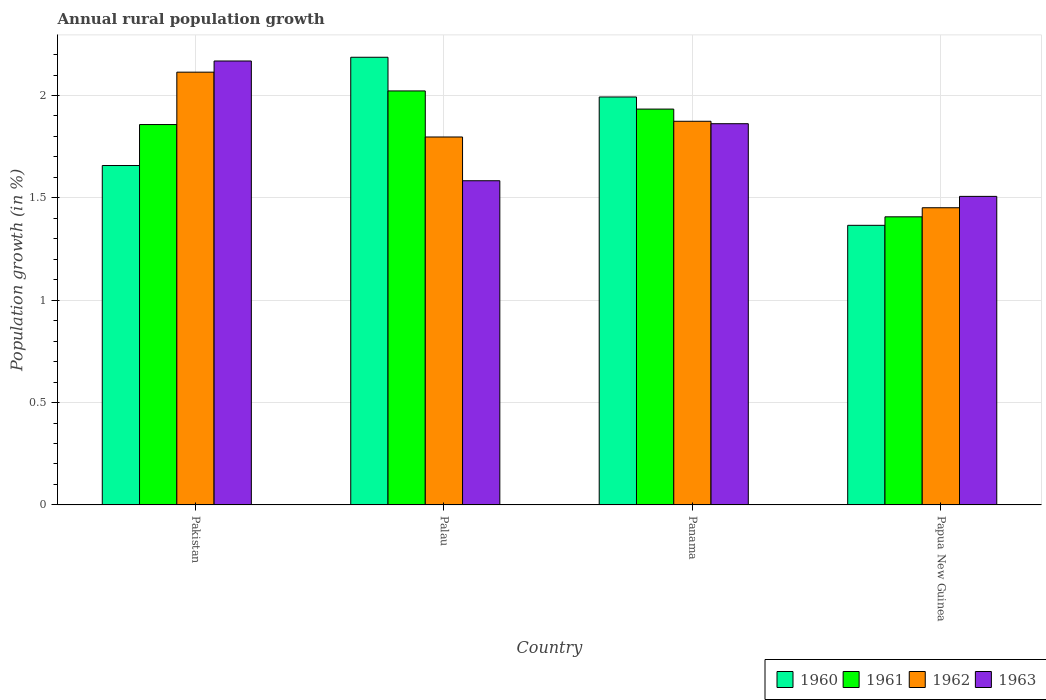Are the number of bars on each tick of the X-axis equal?
Provide a succinct answer. Yes. How many bars are there on the 3rd tick from the right?
Offer a very short reply. 4. What is the label of the 3rd group of bars from the left?
Offer a terse response. Panama. What is the percentage of rural population growth in 1960 in Papua New Guinea?
Your answer should be very brief. 1.37. Across all countries, what is the maximum percentage of rural population growth in 1962?
Provide a succinct answer. 2.11. Across all countries, what is the minimum percentage of rural population growth in 1961?
Make the answer very short. 1.41. In which country was the percentage of rural population growth in 1962 maximum?
Provide a short and direct response. Pakistan. In which country was the percentage of rural population growth in 1963 minimum?
Offer a terse response. Papua New Guinea. What is the total percentage of rural population growth in 1963 in the graph?
Provide a short and direct response. 7.12. What is the difference between the percentage of rural population growth in 1960 in Pakistan and that in Panama?
Your answer should be compact. -0.33. What is the difference between the percentage of rural population growth in 1963 in Pakistan and the percentage of rural population growth in 1961 in Palau?
Keep it short and to the point. 0.15. What is the average percentage of rural population growth in 1962 per country?
Ensure brevity in your answer.  1.81. What is the difference between the percentage of rural population growth of/in 1961 and percentage of rural population growth of/in 1963 in Palau?
Offer a terse response. 0.44. In how many countries, is the percentage of rural population growth in 1961 greater than 0.9 %?
Ensure brevity in your answer.  4. What is the ratio of the percentage of rural population growth in 1963 in Pakistan to that in Palau?
Provide a succinct answer. 1.37. Is the difference between the percentage of rural population growth in 1961 in Palau and Panama greater than the difference between the percentage of rural population growth in 1963 in Palau and Panama?
Provide a short and direct response. Yes. What is the difference between the highest and the second highest percentage of rural population growth in 1962?
Your answer should be compact. -0.24. What is the difference between the highest and the lowest percentage of rural population growth in 1963?
Ensure brevity in your answer.  0.66. In how many countries, is the percentage of rural population growth in 1961 greater than the average percentage of rural population growth in 1961 taken over all countries?
Provide a short and direct response. 3. What does the 4th bar from the left in Palau represents?
Give a very brief answer. 1963. How many countries are there in the graph?
Your response must be concise. 4. Are the values on the major ticks of Y-axis written in scientific E-notation?
Give a very brief answer. No. Does the graph contain grids?
Keep it short and to the point. Yes. What is the title of the graph?
Offer a terse response. Annual rural population growth. Does "1998" appear as one of the legend labels in the graph?
Give a very brief answer. No. What is the label or title of the Y-axis?
Ensure brevity in your answer.  Population growth (in %). What is the Population growth (in %) in 1960 in Pakistan?
Offer a very short reply. 1.66. What is the Population growth (in %) of 1961 in Pakistan?
Offer a very short reply. 1.86. What is the Population growth (in %) in 1962 in Pakistan?
Your response must be concise. 2.11. What is the Population growth (in %) in 1963 in Pakistan?
Provide a short and direct response. 2.17. What is the Population growth (in %) in 1960 in Palau?
Offer a very short reply. 2.19. What is the Population growth (in %) of 1961 in Palau?
Offer a very short reply. 2.02. What is the Population growth (in %) of 1962 in Palau?
Provide a short and direct response. 1.8. What is the Population growth (in %) of 1963 in Palau?
Offer a terse response. 1.58. What is the Population growth (in %) of 1960 in Panama?
Offer a very short reply. 1.99. What is the Population growth (in %) of 1961 in Panama?
Your answer should be compact. 1.93. What is the Population growth (in %) in 1962 in Panama?
Provide a short and direct response. 1.87. What is the Population growth (in %) in 1963 in Panama?
Your answer should be very brief. 1.86. What is the Population growth (in %) in 1960 in Papua New Guinea?
Offer a very short reply. 1.37. What is the Population growth (in %) of 1961 in Papua New Guinea?
Provide a short and direct response. 1.41. What is the Population growth (in %) of 1962 in Papua New Guinea?
Provide a succinct answer. 1.45. What is the Population growth (in %) in 1963 in Papua New Guinea?
Make the answer very short. 1.51. Across all countries, what is the maximum Population growth (in %) in 1960?
Your answer should be very brief. 2.19. Across all countries, what is the maximum Population growth (in %) of 1961?
Keep it short and to the point. 2.02. Across all countries, what is the maximum Population growth (in %) in 1962?
Keep it short and to the point. 2.11. Across all countries, what is the maximum Population growth (in %) of 1963?
Offer a terse response. 2.17. Across all countries, what is the minimum Population growth (in %) in 1960?
Provide a succinct answer. 1.37. Across all countries, what is the minimum Population growth (in %) in 1961?
Ensure brevity in your answer.  1.41. Across all countries, what is the minimum Population growth (in %) in 1962?
Give a very brief answer. 1.45. Across all countries, what is the minimum Population growth (in %) of 1963?
Your answer should be compact. 1.51. What is the total Population growth (in %) of 1960 in the graph?
Give a very brief answer. 7.2. What is the total Population growth (in %) of 1961 in the graph?
Offer a very short reply. 7.22. What is the total Population growth (in %) of 1962 in the graph?
Provide a succinct answer. 7.24. What is the total Population growth (in %) in 1963 in the graph?
Give a very brief answer. 7.12. What is the difference between the Population growth (in %) of 1960 in Pakistan and that in Palau?
Your response must be concise. -0.53. What is the difference between the Population growth (in %) in 1961 in Pakistan and that in Palau?
Make the answer very short. -0.16. What is the difference between the Population growth (in %) of 1962 in Pakistan and that in Palau?
Give a very brief answer. 0.32. What is the difference between the Population growth (in %) in 1963 in Pakistan and that in Palau?
Offer a very short reply. 0.58. What is the difference between the Population growth (in %) of 1960 in Pakistan and that in Panama?
Offer a terse response. -0.33. What is the difference between the Population growth (in %) of 1961 in Pakistan and that in Panama?
Your answer should be compact. -0.08. What is the difference between the Population growth (in %) in 1962 in Pakistan and that in Panama?
Keep it short and to the point. 0.24. What is the difference between the Population growth (in %) of 1963 in Pakistan and that in Panama?
Provide a succinct answer. 0.31. What is the difference between the Population growth (in %) in 1960 in Pakistan and that in Papua New Guinea?
Ensure brevity in your answer.  0.29. What is the difference between the Population growth (in %) of 1961 in Pakistan and that in Papua New Guinea?
Your response must be concise. 0.45. What is the difference between the Population growth (in %) in 1962 in Pakistan and that in Papua New Guinea?
Give a very brief answer. 0.66. What is the difference between the Population growth (in %) of 1963 in Pakistan and that in Papua New Guinea?
Make the answer very short. 0.66. What is the difference between the Population growth (in %) in 1960 in Palau and that in Panama?
Offer a very short reply. 0.19. What is the difference between the Population growth (in %) of 1961 in Palau and that in Panama?
Provide a succinct answer. 0.09. What is the difference between the Population growth (in %) in 1962 in Palau and that in Panama?
Ensure brevity in your answer.  -0.08. What is the difference between the Population growth (in %) of 1963 in Palau and that in Panama?
Keep it short and to the point. -0.28. What is the difference between the Population growth (in %) in 1960 in Palau and that in Papua New Guinea?
Provide a succinct answer. 0.82. What is the difference between the Population growth (in %) of 1961 in Palau and that in Papua New Guinea?
Your response must be concise. 0.61. What is the difference between the Population growth (in %) of 1962 in Palau and that in Papua New Guinea?
Keep it short and to the point. 0.35. What is the difference between the Population growth (in %) of 1963 in Palau and that in Papua New Guinea?
Keep it short and to the point. 0.08. What is the difference between the Population growth (in %) of 1960 in Panama and that in Papua New Guinea?
Make the answer very short. 0.63. What is the difference between the Population growth (in %) in 1961 in Panama and that in Papua New Guinea?
Make the answer very short. 0.53. What is the difference between the Population growth (in %) of 1962 in Panama and that in Papua New Guinea?
Make the answer very short. 0.42. What is the difference between the Population growth (in %) of 1963 in Panama and that in Papua New Guinea?
Give a very brief answer. 0.35. What is the difference between the Population growth (in %) of 1960 in Pakistan and the Population growth (in %) of 1961 in Palau?
Provide a short and direct response. -0.36. What is the difference between the Population growth (in %) in 1960 in Pakistan and the Population growth (in %) in 1962 in Palau?
Make the answer very short. -0.14. What is the difference between the Population growth (in %) in 1960 in Pakistan and the Population growth (in %) in 1963 in Palau?
Your answer should be very brief. 0.07. What is the difference between the Population growth (in %) of 1961 in Pakistan and the Population growth (in %) of 1962 in Palau?
Offer a terse response. 0.06. What is the difference between the Population growth (in %) of 1961 in Pakistan and the Population growth (in %) of 1963 in Palau?
Provide a short and direct response. 0.27. What is the difference between the Population growth (in %) of 1962 in Pakistan and the Population growth (in %) of 1963 in Palau?
Provide a succinct answer. 0.53. What is the difference between the Population growth (in %) of 1960 in Pakistan and the Population growth (in %) of 1961 in Panama?
Offer a very short reply. -0.28. What is the difference between the Population growth (in %) of 1960 in Pakistan and the Population growth (in %) of 1962 in Panama?
Make the answer very short. -0.22. What is the difference between the Population growth (in %) in 1960 in Pakistan and the Population growth (in %) in 1963 in Panama?
Ensure brevity in your answer.  -0.2. What is the difference between the Population growth (in %) of 1961 in Pakistan and the Population growth (in %) of 1962 in Panama?
Your answer should be very brief. -0.02. What is the difference between the Population growth (in %) of 1961 in Pakistan and the Population growth (in %) of 1963 in Panama?
Your response must be concise. -0. What is the difference between the Population growth (in %) of 1962 in Pakistan and the Population growth (in %) of 1963 in Panama?
Provide a short and direct response. 0.25. What is the difference between the Population growth (in %) in 1960 in Pakistan and the Population growth (in %) in 1961 in Papua New Guinea?
Provide a short and direct response. 0.25. What is the difference between the Population growth (in %) in 1960 in Pakistan and the Population growth (in %) in 1962 in Papua New Guinea?
Provide a short and direct response. 0.21. What is the difference between the Population growth (in %) in 1960 in Pakistan and the Population growth (in %) in 1963 in Papua New Guinea?
Provide a short and direct response. 0.15. What is the difference between the Population growth (in %) in 1961 in Pakistan and the Population growth (in %) in 1962 in Papua New Guinea?
Make the answer very short. 0.41. What is the difference between the Population growth (in %) of 1961 in Pakistan and the Population growth (in %) of 1963 in Papua New Guinea?
Offer a terse response. 0.35. What is the difference between the Population growth (in %) in 1962 in Pakistan and the Population growth (in %) in 1963 in Papua New Guinea?
Keep it short and to the point. 0.61. What is the difference between the Population growth (in %) in 1960 in Palau and the Population growth (in %) in 1961 in Panama?
Your answer should be compact. 0.25. What is the difference between the Population growth (in %) of 1960 in Palau and the Population growth (in %) of 1962 in Panama?
Give a very brief answer. 0.31. What is the difference between the Population growth (in %) in 1960 in Palau and the Population growth (in %) in 1963 in Panama?
Your answer should be compact. 0.32. What is the difference between the Population growth (in %) in 1961 in Palau and the Population growth (in %) in 1962 in Panama?
Provide a succinct answer. 0.15. What is the difference between the Population growth (in %) of 1961 in Palau and the Population growth (in %) of 1963 in Panama?
Provide a succinct answer. 0.16. What is the difference between the Population growth (in %) of 1962 in Palau and the Population growth (in %) of 1963 in Panama?
Your answer should be very brief. -0.06. What is the difference between the Population growth (in %) of 1960 in Palau and the Population growth (in %) of 1961 in Papua New Guinea?
Provide a succinct answer. 0.78. What is the difference between the Population growth (in %) of 1960 in Palau and the Population growth (in %) of 1962 in Papua New Guinea?
Keep it short and to the point. 0.73. What is the difference between the Population growth (in %) of 1960 in Palau and the Population growth (in %) of 1963 in Papua New Guinea?
Your answer should be very brief. 0.68. What is the difference between the Population growth (in %) in 1961 in Palau and the Population growth (in %) in 1962 in Papua New Guinea?
Your answer should be very brief. 0.57. What is the difference between the Population growth (in %) of 1961 in Palau and the Population growth (in %) of 1963 in Papua New Guinea?
Provide a short and direct response. 0.52. What is the difference between the Population growth (in %) of 1962 in Palau and the Population growth (in %) of 1963 in Papua New Guinea?
Offer a terse response. 0.29. What is the difference between the Population growth (in %) in 1960 in Panama and the Population growth (in %) in 1961 in Papua New Guinea?
Ensure brevity in your answer.  0.59. What is the difference between the Population growth (in %) in 1960 in Panama and the Population growth (in %) in 1962 in Papua New Guinea?
Keep it short and to the point. 0.54. What is the difference between the Population growth (in %) of 1960 in Panama and the Population growth (in %) of 1963 in Papua New Guinea?
Your answer should be very brief. 0.49. What is the difference between the Population growth (in %) of 1961 in Panama and the Population growth (in %) of 1962 in Papua New Guinea?
Your answer should be very brief. 0.48. What is the difference between the Population growth (in %) in 1961 in Panama and the Population growth (in %) in 1963 in Papua New Guinea?
Give a very brief answer. 0.43. What is the difference between the Population growth (in %) of 1962 in Panama and the Population growth (in %) of 1963 in Papua New Guinea?
Offer a very short reply. 0.37. What is the average Population growth (in %) in 1960 per country?
Offer a terse response. 1.8. What is the average Population growth (in %) in 1961 per country?
Offer a terse response. 1.81. What is the average Population growth (in %) of 1962 per country?
Ensure brevity in your answer.  1.81. What is the average Population growth (in %) in 1963 per country?
Your answer should be compact. 1.78. What is the difference between the Population growth (in %) of 1960 and Population growth (in %) of 1961 in Pakistan?
Give a very brief answer. -0.2. What is the difference between the Population growth (in %) of 1960 and Population growth (in %) of 1962 in Pakistan?
Provide a short and direct response. -0.46. What is the difference between the Population growth (in %) of 1960 and Population growth (in %) of 1963 in Pakistan?
Keep it short and to the point. -0.51. What is the difference between the Population growth (in %) in 1961 and Population growth (in %) in 1962 in Pakistan?
Your answer should be very brief. -0.26. What is the difference between the Population growth (in %) of 1961 and Population growth (in %) of 1963 in Pakistan?
Ensure brevity in your answer.  -0.31. What is the difference between the Population growth (in %) of 1962 and Population growth (in %) of 1963 in Pakistan?
Provide a short and direct response. -0.05. What is the difference between the Population growth (in %) of 1960 and Population growth (in %) of 1961 in Palau?
Provide a succinct answer. 0.16. What is the difference between the Population growth (in %) of 1960 and Population growth (in %) of 1962 in Palau?
Ensure brevity in your answer.  0.39. What is the difference between the Population growth (in %) in 1960 and Population growth (in %) in 1963 in Palau?
Your answer should be very brief. 0.6. What is the difference between the Population growth (in %) in 1961 and Population growth (in %) in 1962 in Palau?
Provide a succinct answer. 0.23. What is the difference between the Population growth (in %) of 1961 and Population growth (in %) of 1963 in Palau?
Provide a short and direct response. 0.44. What is the difference between the Population growth (in %) of 1962 and Population growth (in %) of 1963 in Palau?
Ensure brevity in your answer.  0.21. What is the difference between the Population growth (in %) of 1960 and Population growth (in %) of 1961 in Panama?
Your response must be concise. 0.06. What is the difference between the Population growth (in %) of 1960 and Population growth (in %) of 1962 in Panama?
Provide a short and direct response. 0.12. What is the difference between the Population growth (in %) in 1960 and Population growth (in %) in 1963 in Panama?
Give a very brief answer. 0.13. What is the difference between the Population growth (in %) of 1961 and Population growth (in %) of 1962 in Panama?
Keep it short and to the point. 0.06. What is the difference between the Population growth (in %) of 1961 and Population growth (in %) of 1963 in Panama?
Provide a succinct answer. 0.07. What is the difference between the Population growth (in %) in 1962 and Population growth (in %) in 1963 in Panama?
Your answer should be compact. 0.01. What is the difference between the Population growth (in %) of 1960 and Population growth (in %) of 1961 in Papua New Guinea?
Give a very brief answer. -0.04. What is the difference between the Population growth (in %) of 1960 and Population growth (in %) of 1962 in Papua New Guinea?
Offer a very short reply. -0.09. What is the difference between the Population growth (in %) in 1960 and Population growth (in %) in 1963 in Papua New Guinea?
Give a very brief answer. -0.14. What is the difference between the Population growth (in %) in 1961 and Population growth (in %) in 1962 in Papua New Guinea?
Keep it short and to the point. -0.04. What is the difference between the Population growth (in %) in 1961 and Population growth (in %) in 1963 in Papua New Guinea?
Ensure brevity in your answer.  -0.1. What is the difference between the Population growth (in %) of 1962 and Population growth (in %) of 1963 in Papua New Guinea?
Your answer should be very brief. -0.06. What is the ratio of the Population growth (in %) of 1960 in Pakistan to that in Palau?
Keep it short and to the point. 0.76. What is the ratio of the Population growth (in %) of 1961 in Pakistan to that in Palau?
Your answer should be very brief. 0.92. What is the ratio of the Population growth (in %) in 1962 in Pakistan to that in Palau?
Make the answer very short. 1.18. What is the ratio of the Population growth (in %) of 1963 in Pakistan to that in Palau?
Provide a succinct answer. 1.37. What is the ratio of the Population growth (in %) in 1960 in Pakistan to that in Panama?
Your response must be concise. 0.83. What is the ratio of the Population growth (in %) in 1961 in Pakistan to that in Panama?
Ensure brevity in your answer.  0.96. What is the ratio of the Population growth (in %) in 1962 in Pakistan to that in Panama?
Keep it short and to the point. 1.13. What is the ratio of the Population growth (in %) in 1963 in Pakistan to that in Panama?
Ensure brevity in your answer.  1.16. What is the ratio of the Population growth (in %) of 1960 in Pakistan to that in Papua New Guinea?
Provide a succinct answer. 1.21. What is the ratio of the Population growth (in %) of 1961 in Pakistan to that in Papua New Guinea?
Your answer should be very brief. 1.32. What is the ratio of the Population growth (in %) in 1962 in Pakistan to that in Papua New Guinea?
Offer a terse response. 1.46. What is the ratio of the Population growth (in %) of 1963 in Pakistan to that in Papua New Guinea?
Your answer should be compact. 1.44. What is the ratio of the Population growth (in %) of 1960 in Palau to that in Panama?
Ensure brevity in your answer.  1.1. What is the ratio of the Population growth (in %) in 1961 in Palau to that in Panama?
Keep it short and to the point. 1.05. What is the ratio of the Population growth (in %) in 1962 in Palau to that in Panama?
Provide a succinct answer. 0.96. What is the ratio of the Population growth (in %) of 1963 in Palau to that in Panama?
Your answer should be very brief. 0.85. What is the ratio of the Population growth (in %) of 1960 in Palau to that in Papua New Guinea?
Provide a short and direct response. 1.6. What is the ratio of the Population growth (in %) in 1961 in Palau to that in Papua New Guinea?
Give a very brief answer. 1.44. What is the ratio of the Population growth (in %) in 1962 in Palau to that in Papua New Guinea?
Ensure brevity in your answer.  1.24. What is the ratio of the Population growth (in %) in 1963 in Palau to that in Papua New Guinea?
Your answer should be very brief. 1.05. What is the ratio of the Population growth (in %) in 1960 in Panama to that in Papua New Guinea?
Your response must be concise. 1.46. What is the ratio of the Population growth (in %) of 1961 in Panama to that in Papua New Guinea?
Offer a very short reply. 1.37. What is the ratio of the Population growth (in %) in 1962 in Panama to that in Papua New Guinea?
Offer a terse response. 1.29. What is the ratio of the Population growth (in %) of 1963 in Panama to that in Papua New Guinea?
Your answer should be very brief. 1.24. What is the difference between the highest and the second highest Population growth (in %) in 1960?
Offer a very short reply. 0.19. What is the difference between the highest and the second highest Population growth (in %) of 1961?
Give a very brief answer. 0.09. What is the difference between the highest and the second highest Population growth (in %) in 1962?
Offer a very short reply. 0.24. What is the difference between the highest and the second highest Population growth (in %) of 1963?
Offer a terse response. 0.31. What is the difference between the highest and the lowest Population growth (in %) of 1960?
Your answer should be compact. 0.82. What is the difference between the highest and the lowest Population growth (in %) in 1961?
Provide a short and direct response. 0.61. What is the difference between the highest and the lowest Population growth (in %) of 1962?
Offer a terse response. 0.66. What is the difference between the highest and the lowest Population growth (in %) in 1963?
Your answer should be compact. 0.66. 